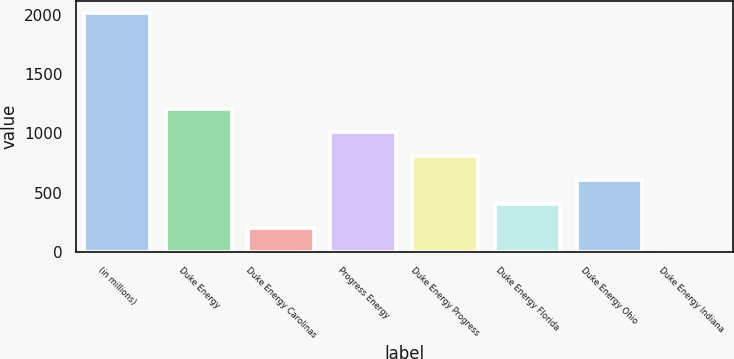Convert chart to OTSL. <chart><loc_0><loc_0><loc_500><loc_500><bar_chart><fcel>(in millions)<fcel>Duke Energy<fcel>Duke Energy Carolinas<fcel>Progress Energy<fcel>Duke Energy Progress<fcel>Duke Energy Florida<fcel>Duke Energy Ohio<fcel>Duke Energy Indiana<nl><fcel>2016<fcel>1210<fcel>202.5<fcel>1008.5<fcel>807<fcel>404<fcel>605.5<fcel>1<nl></chart> 